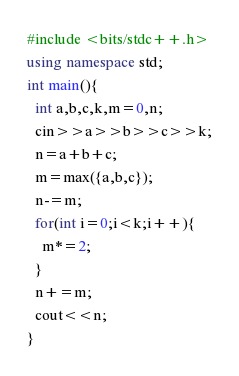<code> <loc_0><loc_0><loc_500><loc_500><_C++_>#include <bits/stdc++.h>
using namespace std;
int main(){
  int a,b,c,k,m=0,n;
  cin>>a>>b>>c>>k;
  n=a+b+c;
  m=max({a,b,c});
  n-=m;
  for(int i=0;i<k;i++){
    m*=2;
  }
  n+=m;
  cout<<n;
}</code> 